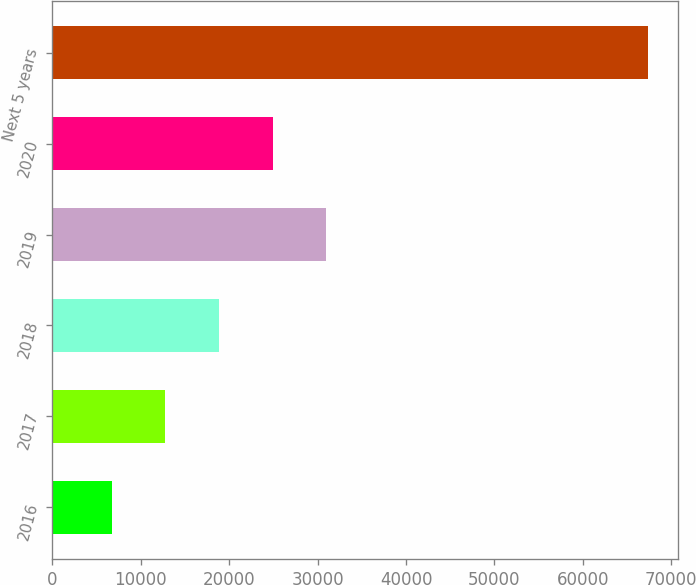<chart> <loc_0><loc_0><loc_500><loc_500><bar_chart><fcel>2016<fcel>2017<fcel>2018<fcel>2019<fcel>2020<fcel>Next 5 years<nl><fcel>6709<fcel>12779.7<fcel>18850.4<fcel>30991.8<fcel>24921.1<fcel>67416<nl></chart> 